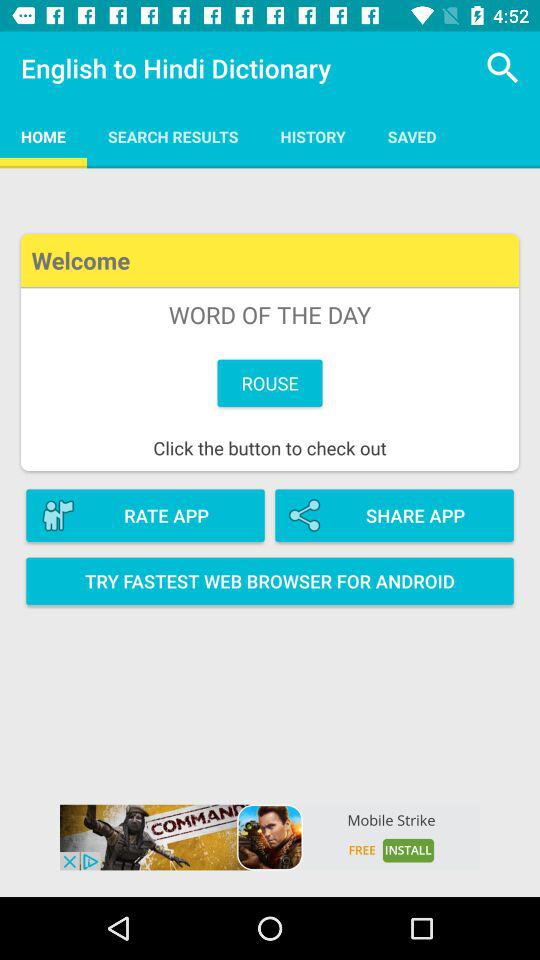What is the word of the day? The word of the day is "ROUSE". 